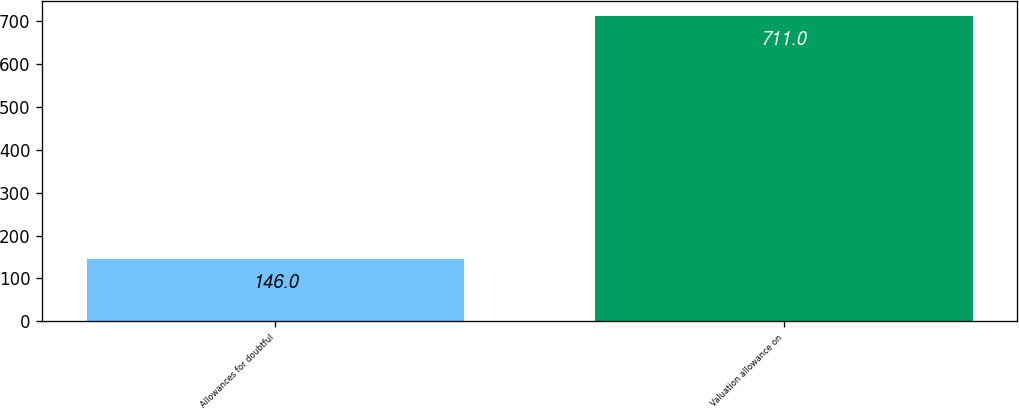<chart> <loc_0><loc_0><loc_500><loc_500><bar_chart><fcel>Allowances for doubtful<fcel>Valuation allowance on<nl><fcel>146<fcel>711<nl></chart> 